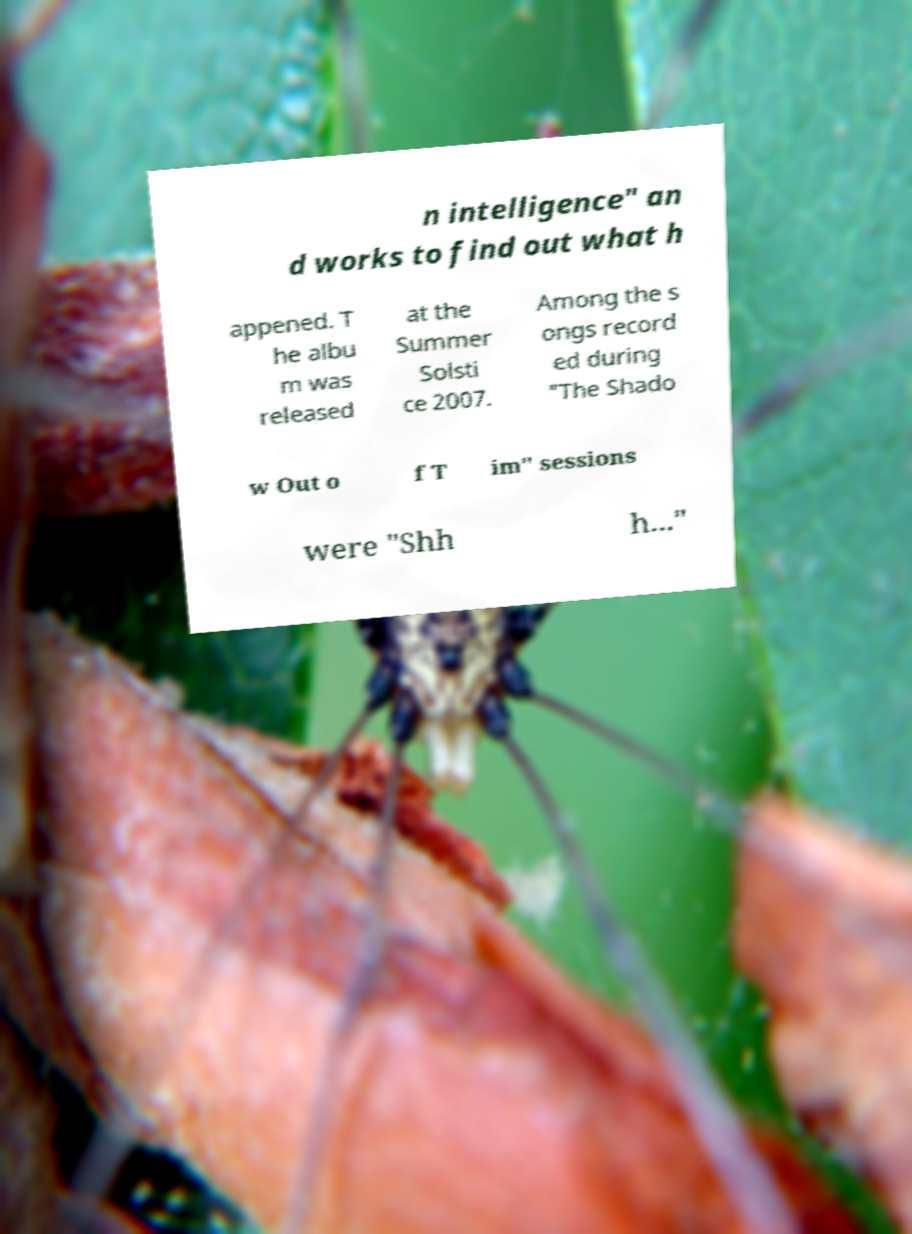Could you extract and type out the text from this image? n intelligence" an d works to find out what h appened. T he albu m was released at the Summer Solsti ce 2007. Among the s ongs record ed during "The Shado w Out o f T im" sessions were "Shh h..." 